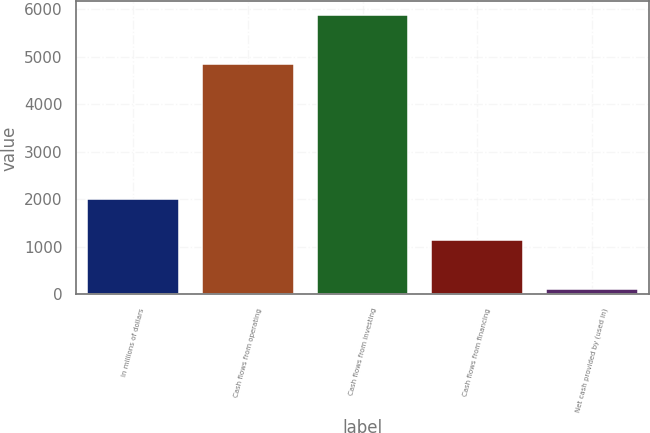Convert chart. <chart><loc_0><loc_0><loc_500><loc_500><bar_chart><fcel>In millions of dollars<fcel>Cash flows from operating<fcel>Cash flows from investing<fcel>Cash flows from financing<fcel>Net cash provided by (used in)<nl><fcel>2006<fcel>4842<fcel>5871<fcel>1150<fcel>121<nl></chart> 